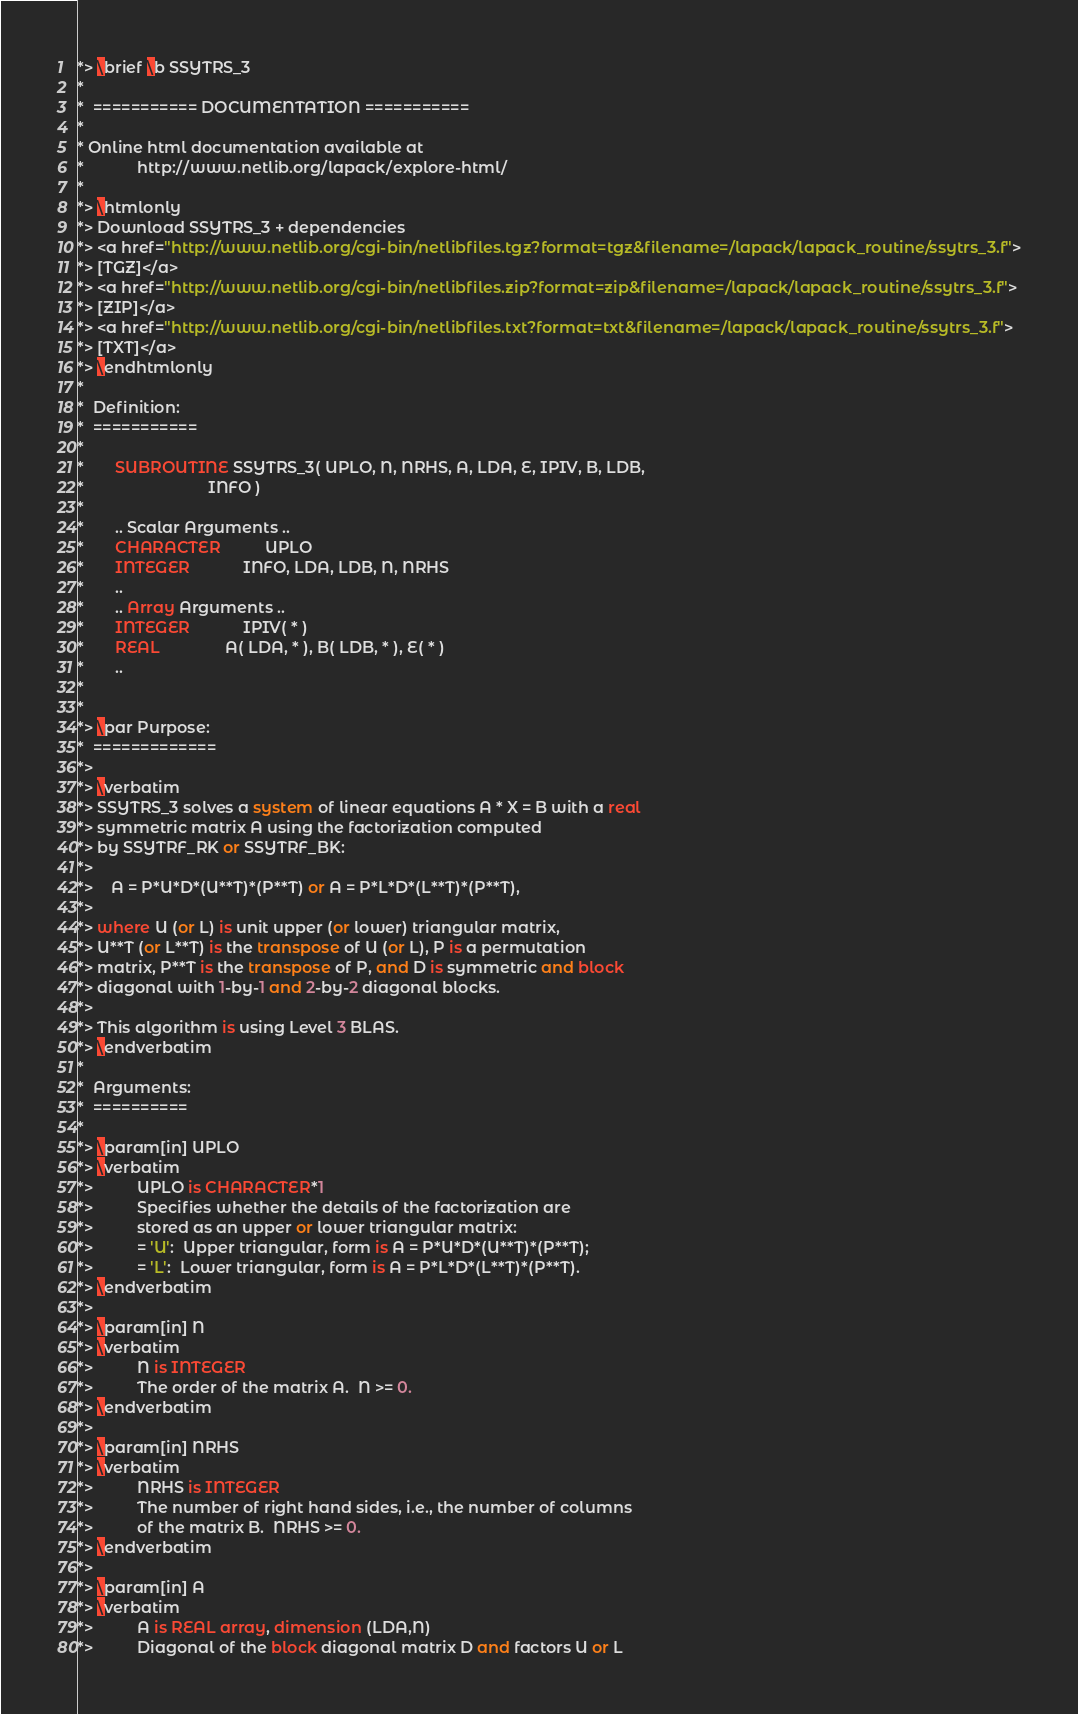<code> <loc_0><loc_0><loc_500><loc_500><_FORTRAN_>*> \brief \b SSYTRS_3
*
*  =========== DOCUMENTATION ===========
*
* Online html documentation available at
*            http://www.netlib.org/lapack/explore-html/
*
*> \htmlonly
*> Download SSYTRS_3 + dependencies
*> <a href="http://www.netlib.org/cgi-bin/netlibfiles.tgz?format=tgz&filename=/lapack/lapack_routine/ssytrs_3.f">
*> [TGZ]</a>
*> <a href="http://www.netlib.org/cgi-bin/netlibfiles.zip?format=zip&filename=/lapack/lapack_routine/ssytrs_3.f">
*> [ZIP]</a>
*> <a href="http://www.netlib.org/cgi-bin/netlibfiles.txt?format=txt&filename=/lapack/lapack_routine/ssytrs_3.f">
*> [TXT]</a>
*> \endhtmlonly
*
*  Definition:
*  ===========
*
*       SUBROUTINE SSYTRS_3( UPLO, N, NRHS, A, LDA, E, IPIV, B, LDB,
*                            INFO )
*
*       .. Scalar Arguments ..
*       CHARACTER          UPLO
*       INTEGER            INFO, LDA, LDB, N, NRHS
*       ..
*       .. Array Arguments ..
*       INTEGER            IPIV( * )
*       REAL               A( LDA, * ), B( LDB, * ), E( * )
*       ..
*
*
*> \par Purpose:
*  =============
*>
*> \verbatim
*> SSYTRS_3 solves a system of linear equations A * X = B with a real
*> symmetric matrix A using the factorization computed
*> by SSYTRF_RK or SSYTRF_BK:
*>
*>    A = P*U*D*(U**T)*(P**T) or A = P*L*D*(L**T)*(P**T),
*>
*> where U (or L) is unit upper (or lower) triangular matrix,
*> U**T (or L**T) is the transpose of U (or L), P is a permutation
*> matrix, P**T is the transpose of P, and D is symmetric and block
*> diagonal with 1-by-1 and 2-by-2 diagonal blocks.
*>
*> This algorithm is using Level 3 BLAS.
*> \endverbatim
*
*  Arguments:
*  ==========
*
*> \param[in] UPLO
*> \verbatim
*>          UPLO is CHARACTER*1
*>          Specifies whether the details of the factorization are
*>          stored as an upper or lower triangular matrix:
*>          = 'U':  Upper triangular, form is A = P*U*D*(U**T)*(P**T);
*>          = 'L':  Lower triangular, form is A = P*L*D*(L**T)*(P**T).
*> \endverbatim
*>
*> \param[in] N
*> \verbatim
*>          N is INTEGER
*>          The order of the matrix A.  N >= 0.
*> \endverbatim
*>
*> \param[in] NRHS
*> \verbatim
*>          NRHS is INTEGER
*>          The number of right hand sides, i.e., the number of columns
*>          of the matrix B.  NRHS >= 0.
*> \endverbatim
*>
*> \param[in] A
*> \verbatim
*>          A is REAL array, dimension (LDA,N)
*>          Diagonal of the block diagonal matrix D and factors U or L</code> 